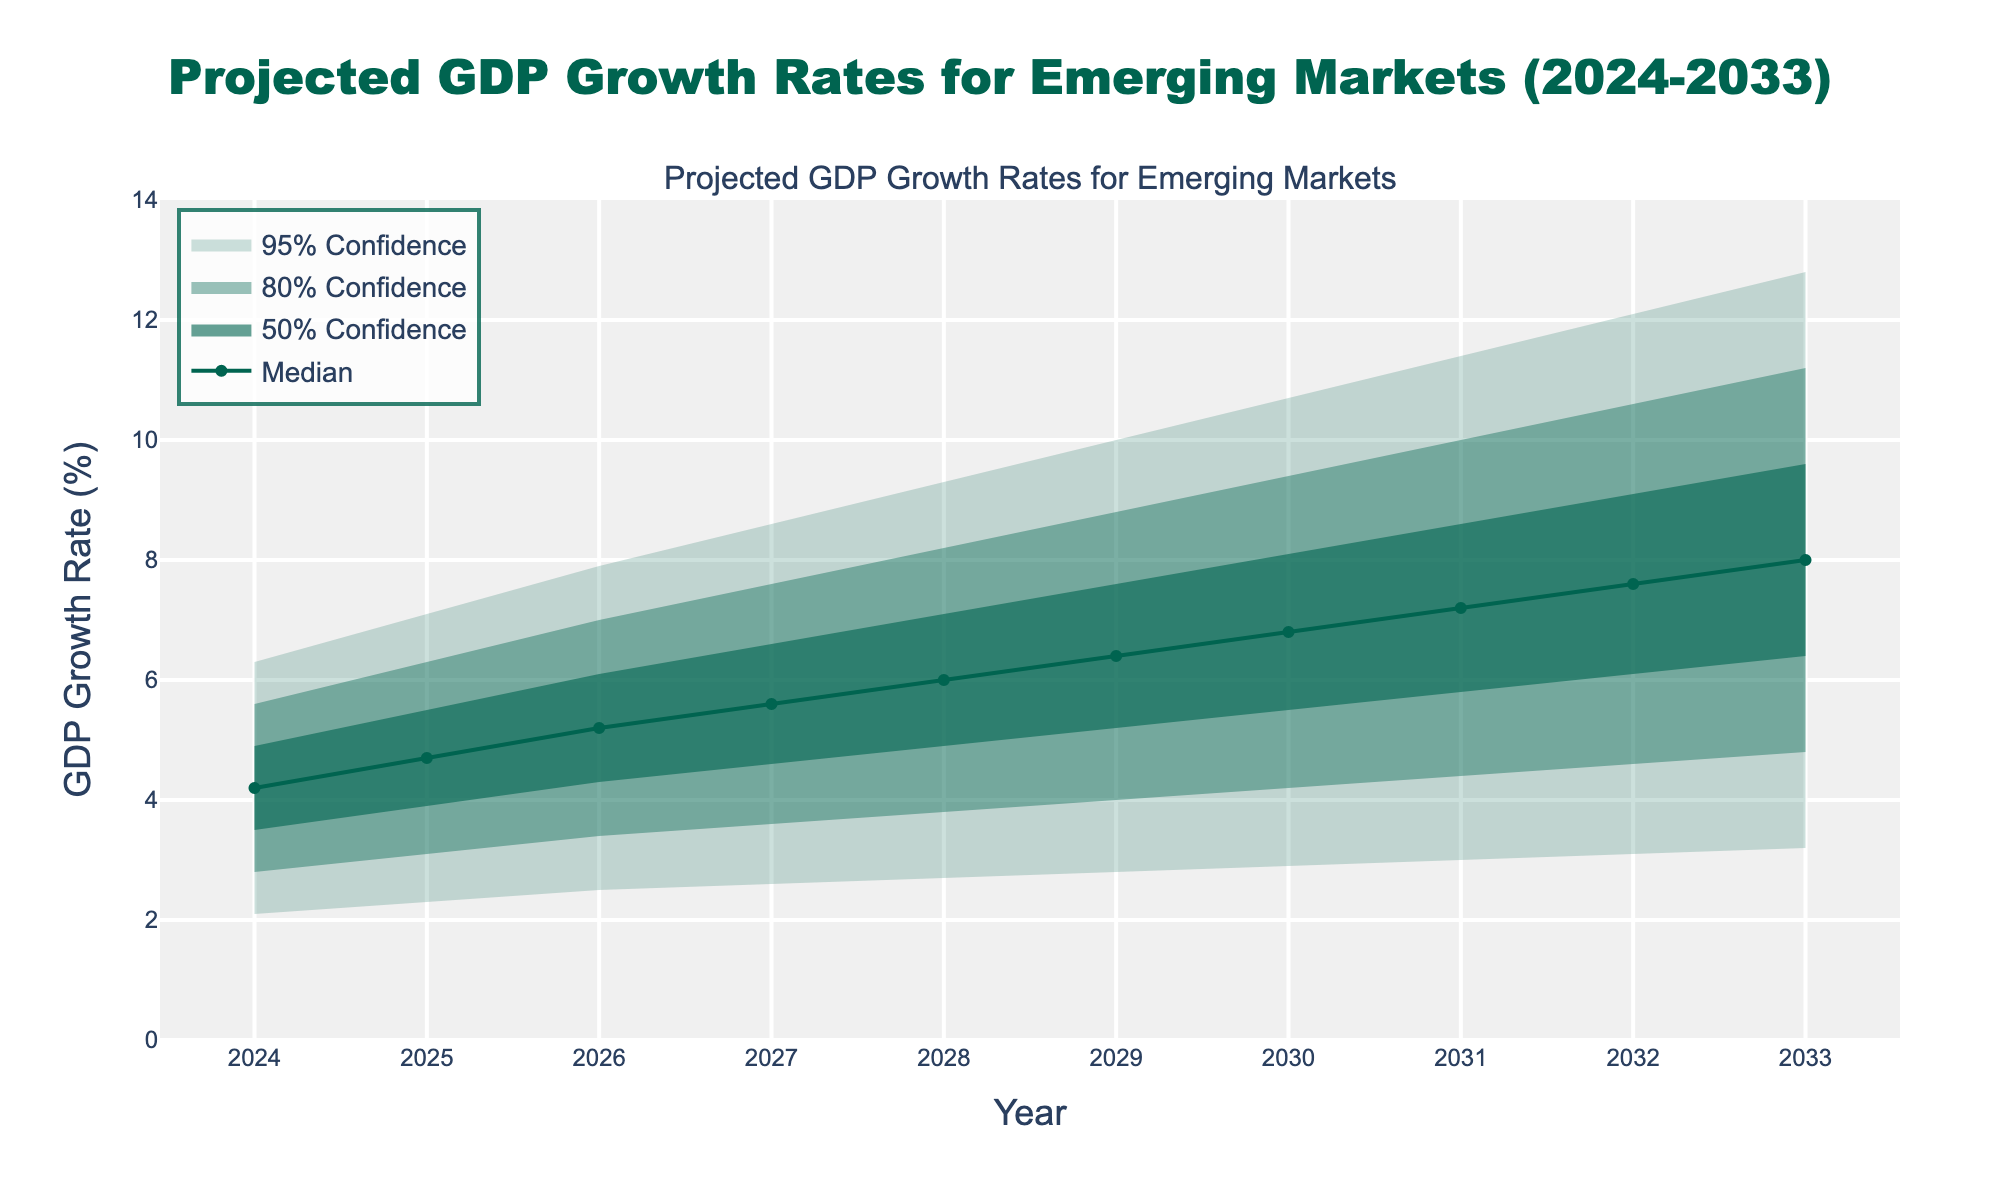What is the title of the figure? The title is stated at the top of the figure. It reads "Projected GDP Growth Rates for Emerging Markets (2024-2033)".
Answer: Projected GDP Growth Rates for Emerging Markets (2024-2033) What color represents the 95% confidence interval in the figure? The 95% confidence interval is shown using the lightest shade of green, which is semi-transparent.
Answer: Light green What is the median projected GDP growth rate for the year 2027? The median value is represented by the solid line and can be read directly from the y-axis value corresponding to the year 2027.
Answer: 5.6% How does the projected median GDP growth rate change from 2024 to 2033? The projected median GDP growth rate starts at 4.2% in 2024 and increases to 8.0% by 2033. This shows a steady increase over the years.
Answer: Increases What is the range of GDP growth rates within the 80% confidence interval for 2028? The 80% confidence interval spans from the lower bound of 3.8% to the upper bound of 8.2% for the year 2028.
Answer: 3.8% to 8.2% Which year shows the largest spread in the 95% confidence interval for GDP growth rates? By comparing the 95% confidence intervals for each year, the year 2033 displays the widest spread, with the lower bound at 3.2% and the upper bound at 12.8%.
Answer: 2033 Between which years does the median GDP growth rate cross the 6% mark? Observing the median line, it crosses the 6% mark between the years 2027 and 2028.
Answer: Between 2027 and 2028 How do the upper and lower bounds of the 50% confidence interval for the year 2031 compare? For 2031, the lower bound of the 50% confidence interval is 5.8% and the upper bound is 9.1%.
Answer: Lower: 5.8%, Upper: 9.1% What is the projected median GDP growth rate from 2024 to 2033 on average? To find the average, sum the median values from each year and divide by the number of years (4.2 + 4.7 + 5.2 + 5.6 + 6.0 + 6.4 + 6.8 + 7.2 + 7.6 + 8.0) / 10 = 61.7 / 10.
Answer: 6.17% In which year does the upper bound of the 80% confidence interval first exceed 10%? Reviewing the upper bound of the 80% confidence interval line, it first exceeds the 10% mark in the year 2031.
Answer: 2031 